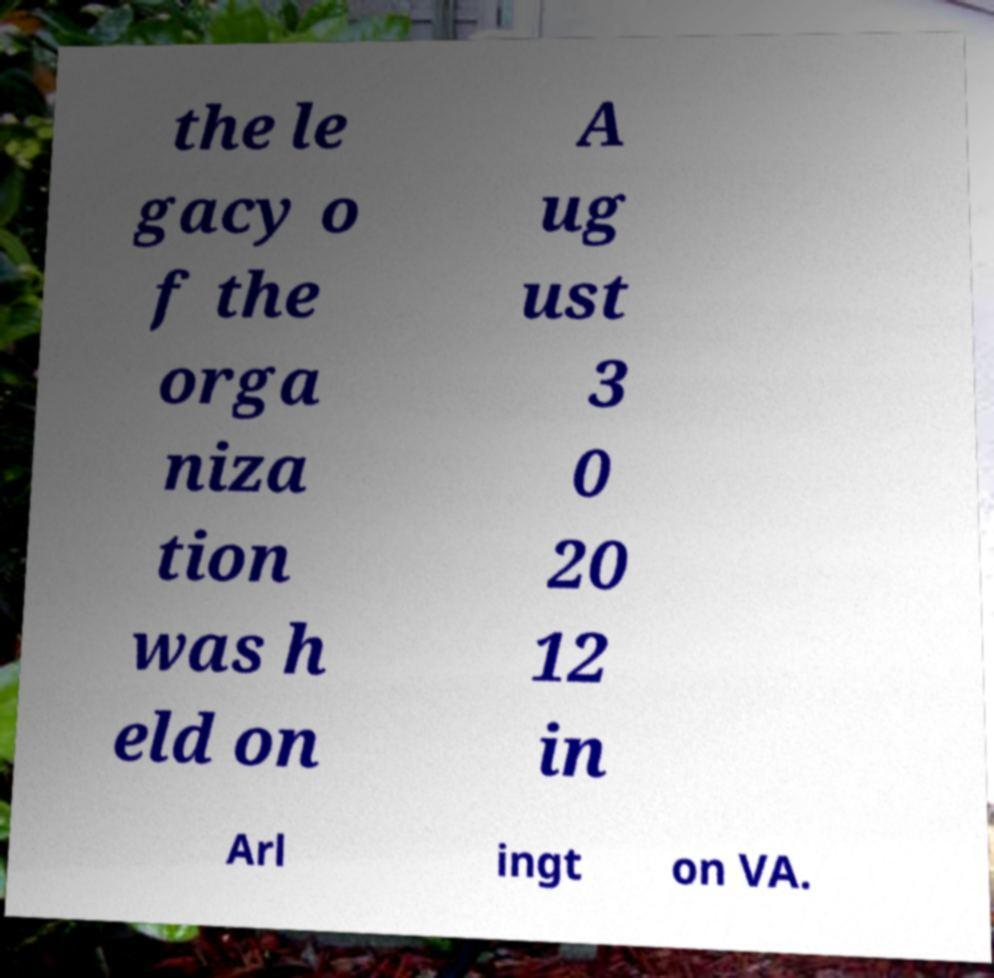Can you accurately transcribe the text from the provided image for me? the le gacy o f the orga niza tion was h eld on A ug ust 3 0 20 12 in Arl ingt on VA. 